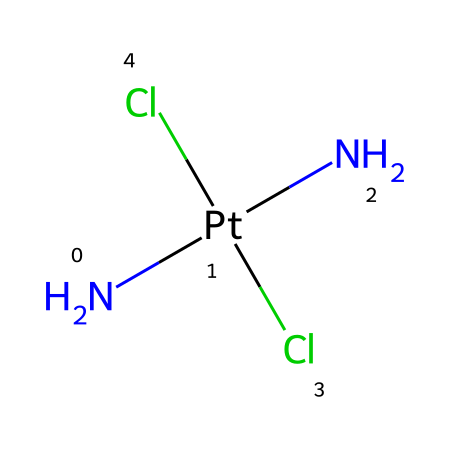What is the central metal atom in this compound? The structure shows a platinum atom (Pt) at the center, which is indicated by its symbol in the SMILES notation.
Answer: platinum How many chloride ligands are present in cisplatin? The SMILES notation includes two Cl (chloride) atoms, indicating that there are two chloride ligands attached to the platinum.
Answer: two What type of ligand is represented by the nitrogen atoms in this structure? The two nitrogen atoms (N) directly bonded to the platinum are amine ligands, which are characterized by having a nitrogen atom bonded to the central metal.
Answer: amine What is the coordination number of the platinum in cisplatin? Coordination number refers to the number of ligands directly bonded to the central metal atom. In this case, there are four atoms (two Cl and two N) around the platinum atom, making the coordination number four.
Answer: four Is cisplatin a square planar or tetrahedral complex? Upon examining the spatial arrangements of the ligands around the platinum atom, cisplatin is known to adopt a square planar geometry due to the specific ligand interactions.
Answer: square planar What therapeutic property does cisplatin provide? Cisplatin is primarily used for its cytotoxic effects to kill cancer cells, making it an effective chemotherapy drug in cancer treatment.
Answer: cytotoxic 